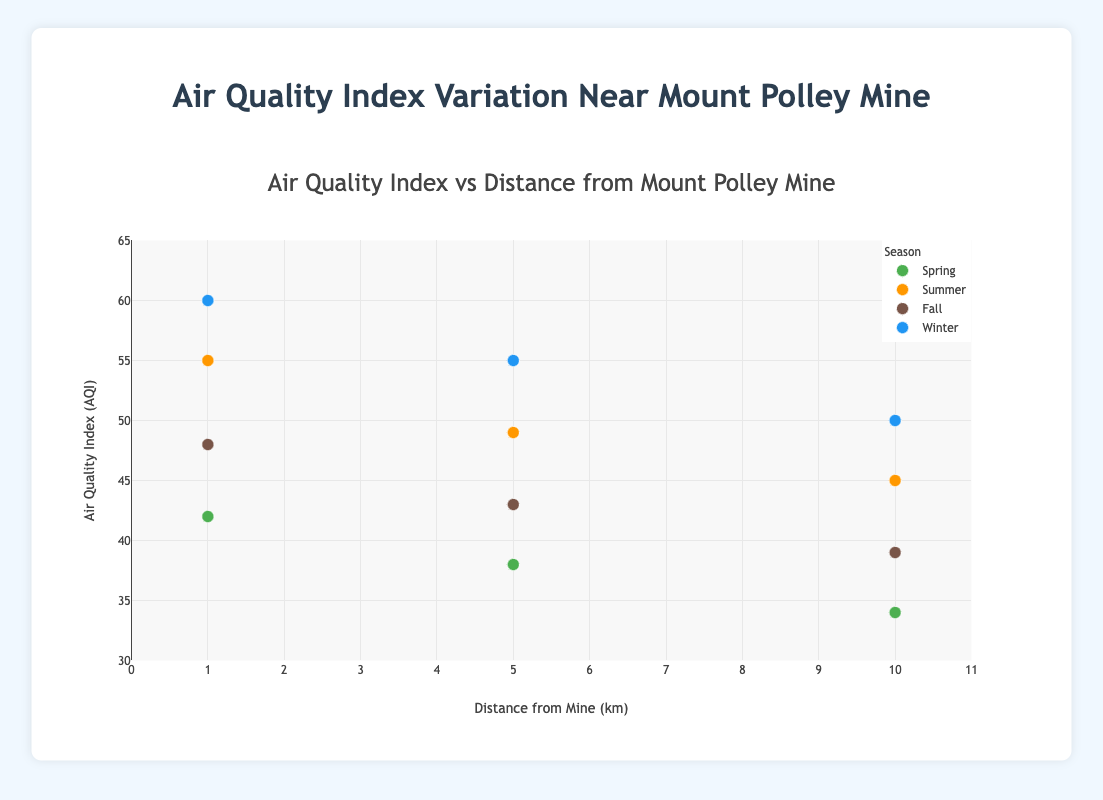What is the air quality index (AQI) at a distance of 1 km from the mine during Winter? Look at the data point corresponding to Winter (blue) at the 1 km distance on the x-axis to find the AQI.
Answer: 60 In which season is the AQI consistently highest across the distances measured? Compare the AQI values from different seasons at the same distances. Summer has the consistently higher AQI values at all distances.
Answer: Summer By how much does the AQI drop from 1 km to 10 km distance during Spring? The AQI at 1 km in Spring is 42 and at 10 km is 34. The drop is 42 - 34.
Answer: 8 Which location has the highest AQI in all seasons, and what is its value? Check the highest AQI value on the plot across all locations and seasons. The highest AQI is during Winter at a distance of 1 km (Home).
Answer: 60 Which season has the lowest AQI at the 5 km distance? Look at the AQI values at 5 km for each season and find the minimum. Spring has the AQI of 38.
Answer: Spring What is the average AQI at the 1 km distance across all seasons? Sum the AQI at 1 km for all seasons (42 + 55 + 48 + 60) and divide by 4. (205 / 4 = 51.25)
Answer: 51.25 Is there a general trend in the AQI as the distance from the mine increases? By observing the plot, it appears the AQI generally decreases as the distance increases for all seasons.
Answer: Yes How much does the AQI increase from Fall to Winter at the Local Park (5 km)? The AQI in Fall at 5 km is 43 and in Winter it is 55. The increase is 55 - 43.
Answer: 12 In which season is the variability in AQI with distance the greatest? Examine the range of AQI values for each season. Winter has the greatest variability (from 60 at 1 km to 50 at 10 km).
Answer: Winter What is the difference in AQI between Summer and Fall at the Small Town (10 km)? Find the AQI values at 10 km for Summer (45) and Fall (39). The difference is 45 - 39.
Answer: 6 